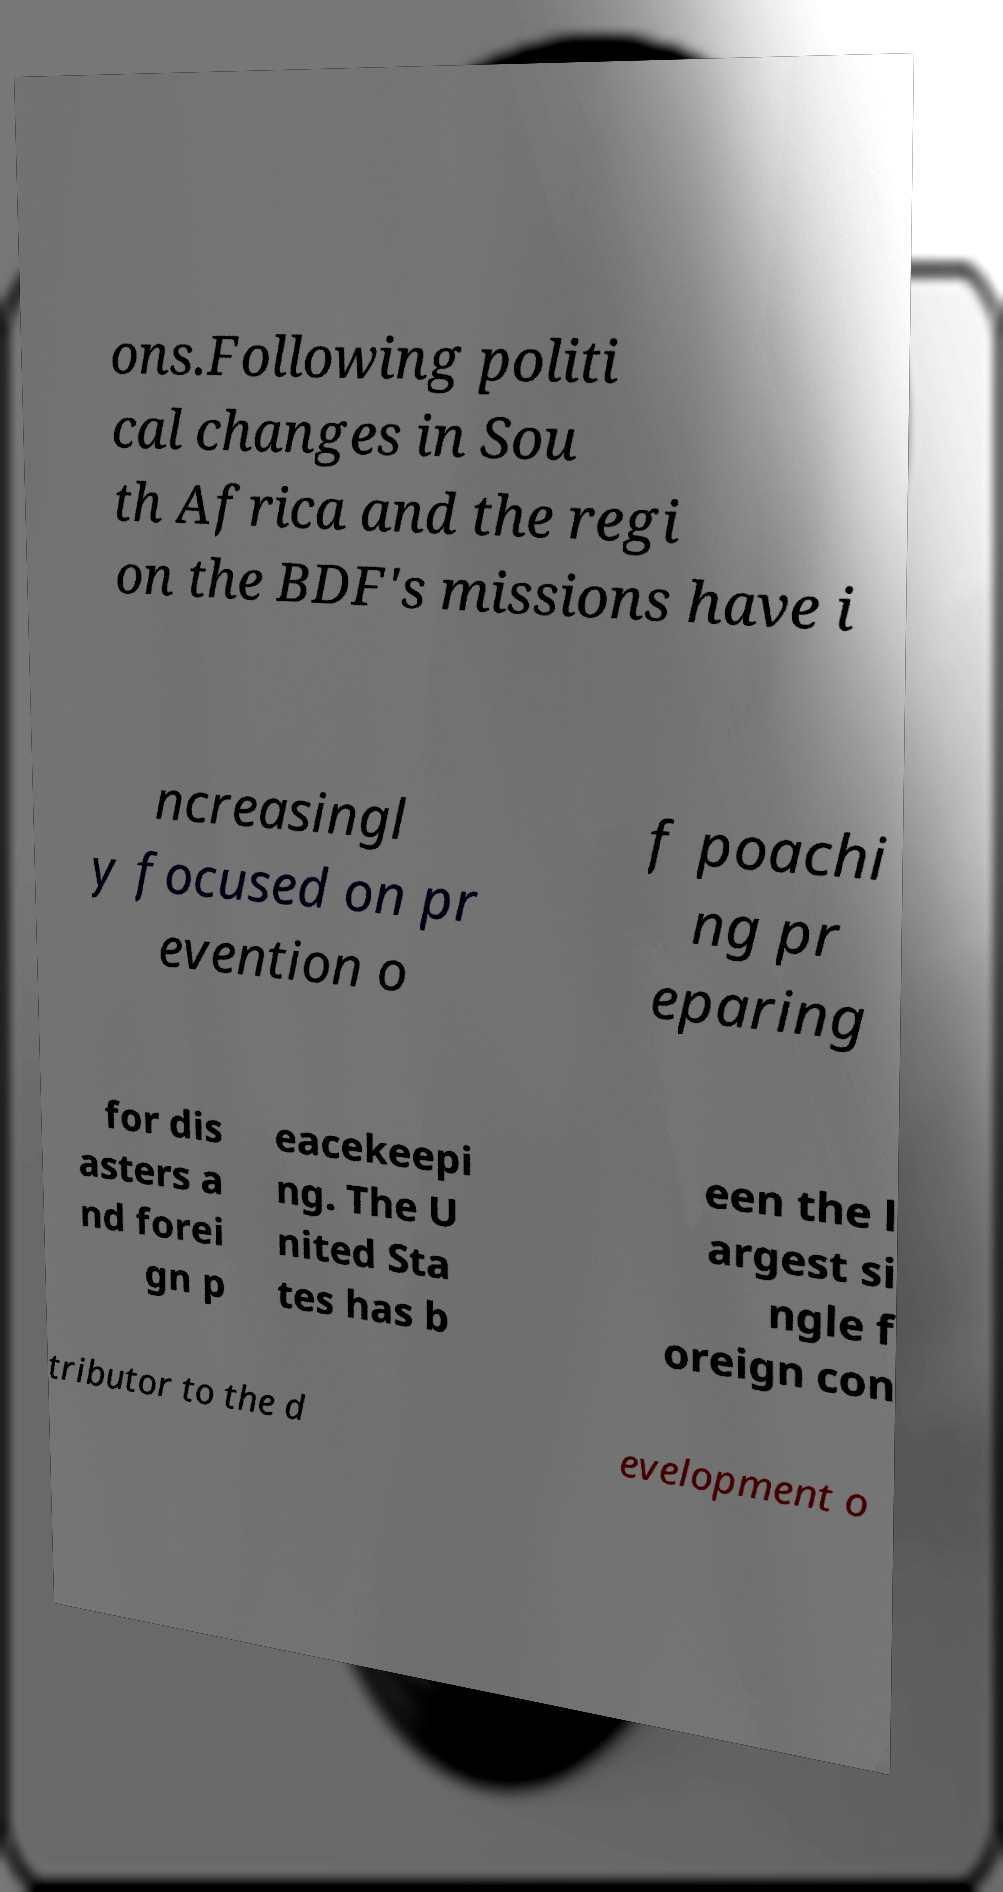Please read and relay the text visible in this image. What does it say? ons.Following politi cal changes in Sou th Africa and the regi on the BDF's missions have i ncreasingl y focused on pr evention o f poachi ng pr eparing for dis asters a nd forei gn p eacekeepi ng. The U nited Sta tes has b een the l argest si ngle f oreign con tributor to the d evelopment o 